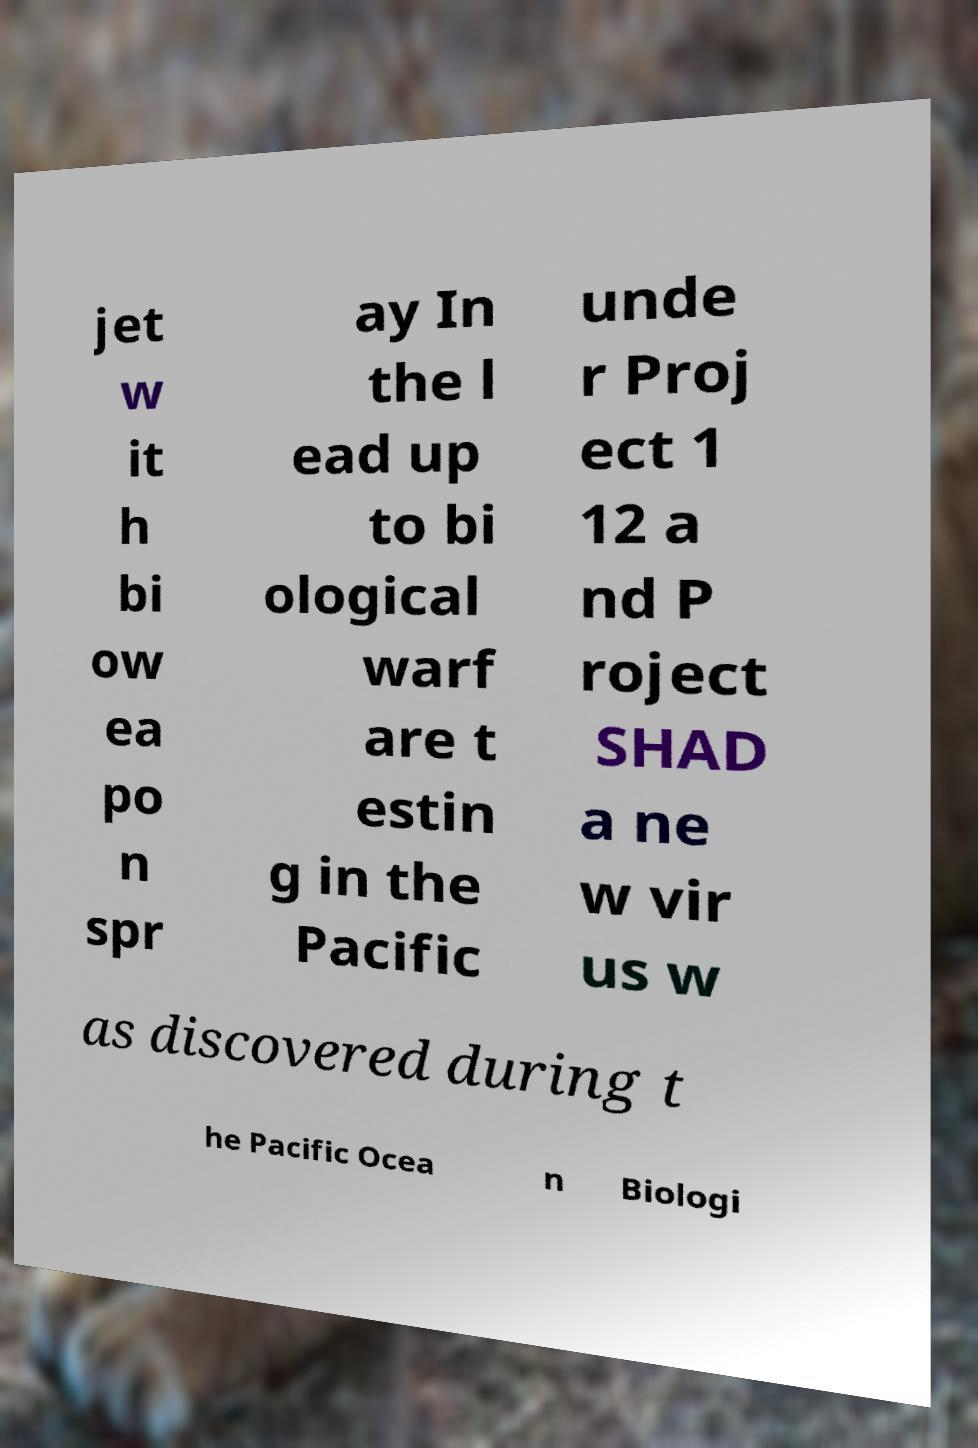Could you assist in decoding the text presented in this image and type it out clearly? jet w it h bi ow ea po n spr ay In the l ead up to bi ological warf are t estin g in the Pacific unde r Proj ect 1 12 a nd P roject SHAD a ne w vir us w as discovered during t he Pacific Ocea n Biologi 